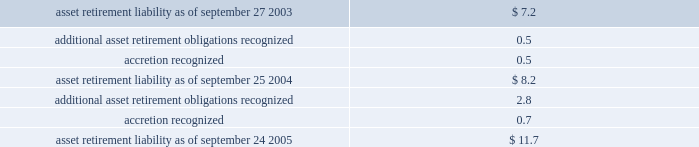Notes to consolidated financial statements ( continued ) note 1 2014summary of significant accounting policies ( continued ) asset retirement obligations the company records obligations associated with the retirement of tangible long-lived assets and the associated asset retirement costs in accordance with sfas no .
143 , accounting for asset retirement obligations .
The company reviews legal obligations associated with the retirement of long-lived assets that result from the acquisition , construction , development and/or normal use of the assets .
If it is determined that a legal obligation exists , the fair value of the liability for an asset retirement obligation is recognized in the period in which it is incurred if a reasonable estimate of fair value can be made .
The fair value of the liability is added to the carrying amount of the associated asset and this additional carrying amount is depreciated over the life of the asset .
The difference between the gross expected future cash flow and its present value is accreted over the life of the related lease as an operating expense .
All of the company 2019s existing asset retirement obligations are associated with commitments to return property subject to operating leases to original condition upon lease termination .
The table reconciles changes in the company 2019s asset retirement liabilities for fiscal 2004 and 2005 ( in millions ) : .
Cumulative effects of accounting changes in 2003 , the company recognized a net favorable cumulative effect type adjustment of approximately $ 1 million from the adoption of sfas no .
150 , accounting for certain financial instruments with characteristic of both liabilities and equity and sfas no .
143 .
Long-lived assets including goodwill and other acquired intangible assets the company reviews property , plant , and equipment and certain identifiable intangibles , excluding goodwill , for impairment whenever events or changes in circumstances indicate the carrying amount of an asset may not be recoverable .
Recoverability of these assets is measured by comparison of its carrying amount to future undiscounted cash flows the assets are expected to generate .
If property , plant , and equipment and certain identifiable intangibles are considered to be impaired , the impairment to be recognized equals the amount by which the carrying value of the assets exceeds its fair market value .
For the three fiscal years ended september 24 , 2005 , the company had no material impairment of its long-lived assets , except for the impairment of certain assets in connection with the restructuring actions described in note 5 of these notes to consolidated financial statements .
Sfas no .
142 , goodwill and other intangible assets requires that goodwill and intangible assets with indefinite useful lives should not be amortized but rather be tested for impairment at least annually or sooner whenever events or changes in circumstances indicate that they may be impaired .
The company performs its goodwill impairment tests on or about august 30 of each year .
The company did not recognize any goodwill or intangible asset impairment charges in 2005 , 2004 , or 2003 .
The company established reporting units based on its current reporting structure .
For purposes of testing goodwill for .
Excluding 2005 accretion expenses . what would the asset retirement liability equal as of september 24 2005? 
Computations: (11.7 - 0.7)
Answer: 11.0. 